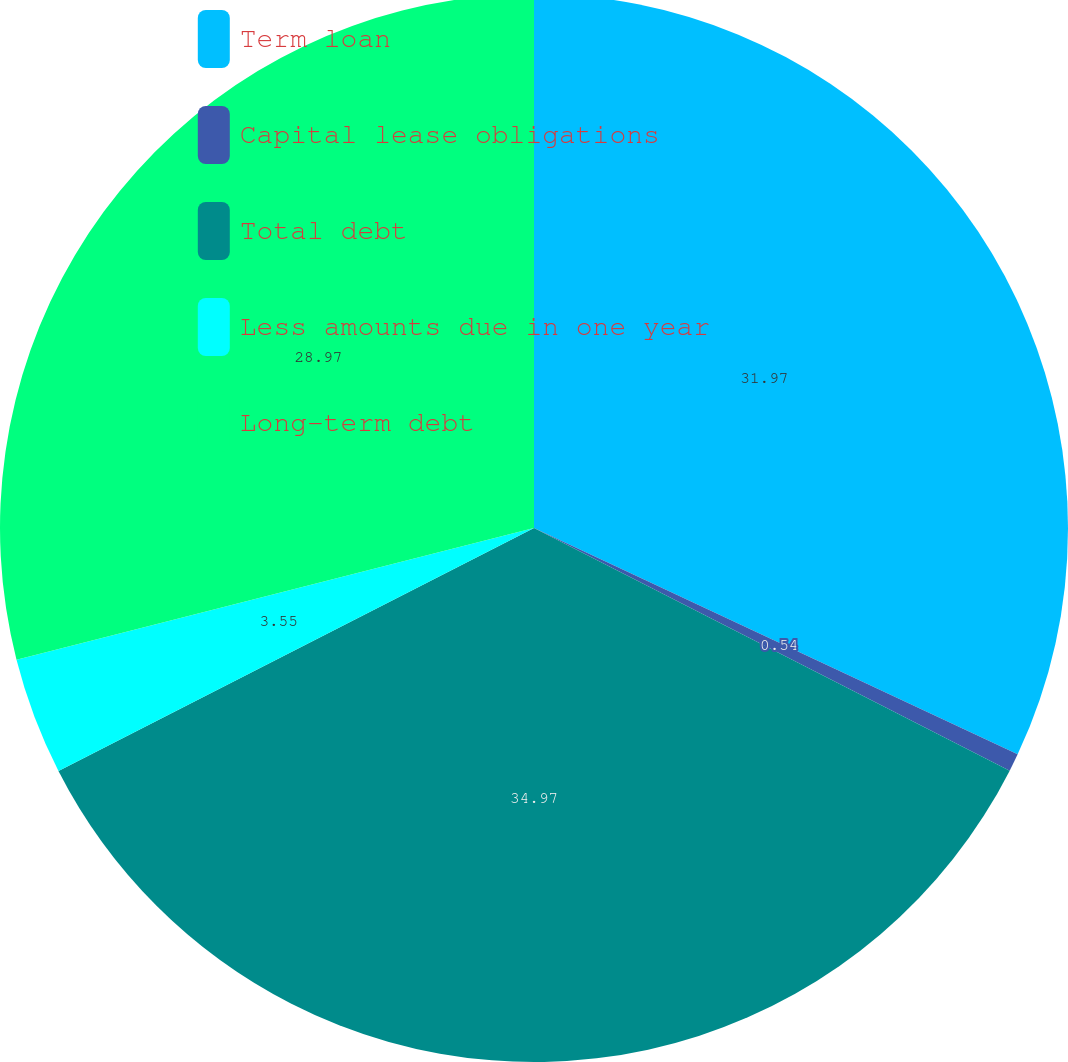Convert chart. <chart><loc_0><loc_0><loc_500><loc_500><pie_chart><fcel>Term loan<fcel>Capital lease obligations<fcel>Total debt<fcel>Less amounts due in one year<fcel>Long-term debt<nl><fcel>31.97%<fcel>0.54%<fcel>34.98%<fcel>3.55%<fcel>28.97%<nl></chart> 